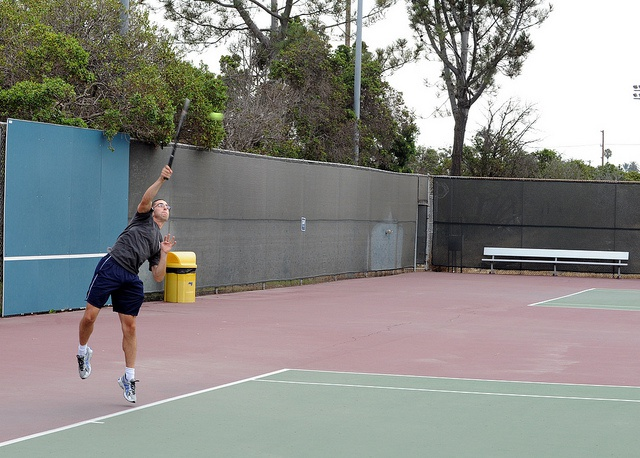Describe the objects in this image and their specific colors. I can see people in darkgray, black, brown, gray, and navy tones, bench in darkgray, lightgray, black, and gray tones, tennis racket in darkgray, gray, black, and darkgreen tones, and sports ball in darkgray, olive, and lightgreen tones in this image. 